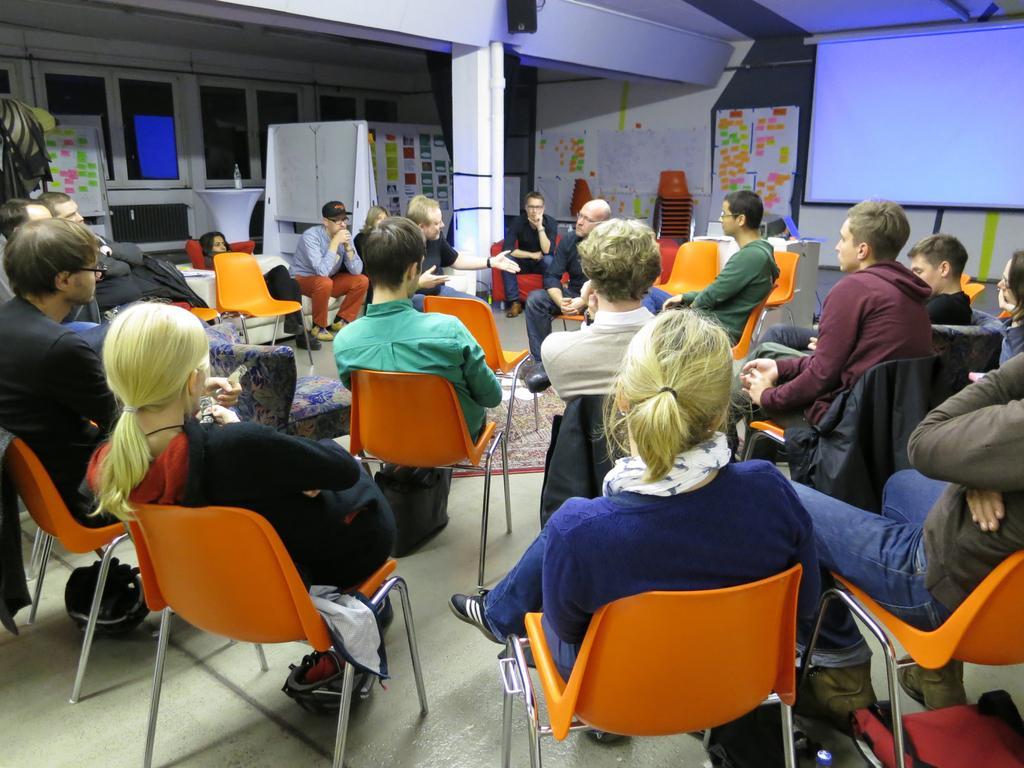Please provide a concise description of this image. People are sitting on the chair,this is screen,this are windows. 